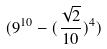<formula> <loc_0><loc_0><loc_500><loc_500>( 9 ^ { 1 0 } - ( \frac { \sqrt { 2 } } { 1 0 } ) ^ { 4 } )</formula> 